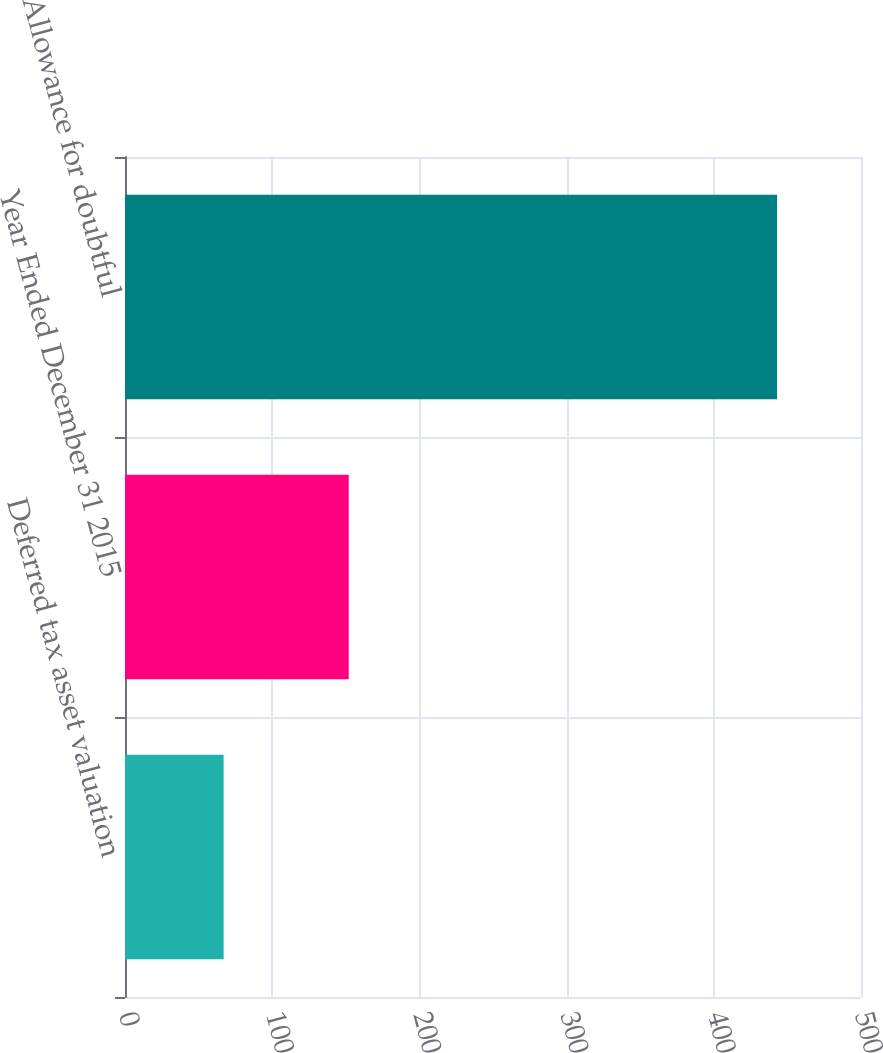Convert chart to OTSL. <chart><loc_0><loc_0><loc_500><loc_500><bar_chart><fcel>Deferred tax asset valuation<fcel>Year Ended December 31 2015<fcel>Allowance for doubtful<nl><fcel>67<fcel>152<fcel>443<nl></chart> 